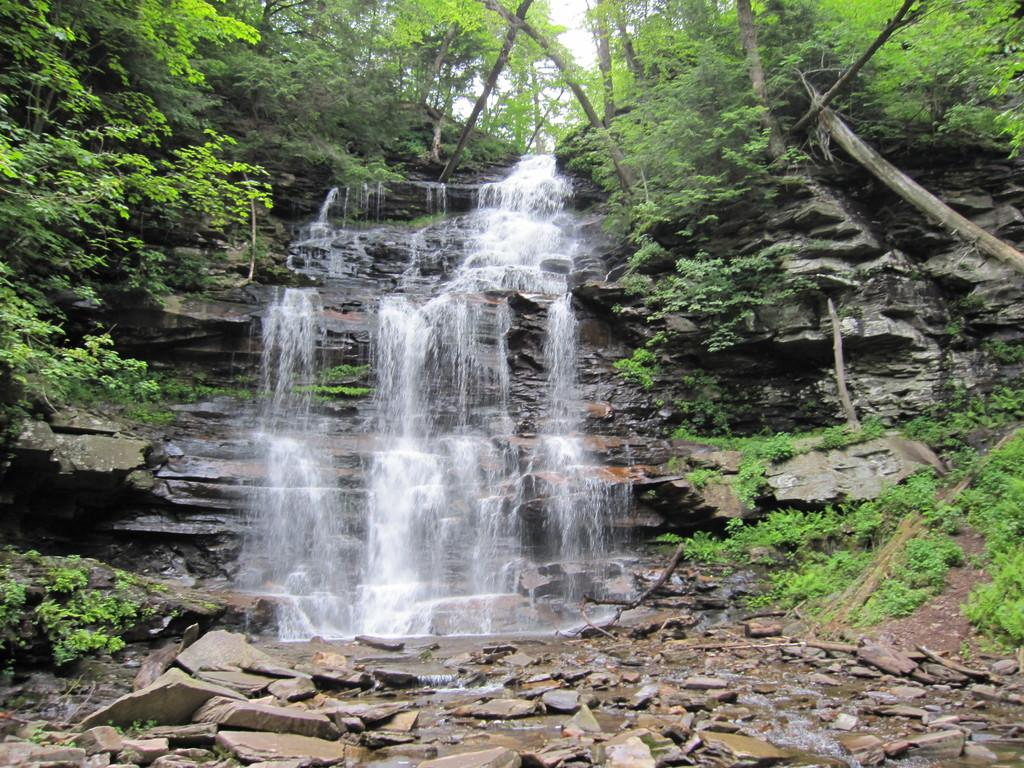What natural feature is the main subject of the image? There is a waterfall in the image. How is the waterfall described? The waterfall is described as beautiful. What type of vegetation is present around the waterfall? There are many plants and trees around the waterfall. What is the condition of the stones under the waterfallen under the waterfall? There are broken stones under the waterfall. How many balls are rolling down the waterfall in the image? There are no balls present in the image; it features a waterfall with plants, trees, and broken stones. What type of fowl can be seen flying near the waterfall in the image? There is no fowl present in the image; it only features a waterfall, plants, trees, and broken stones. 